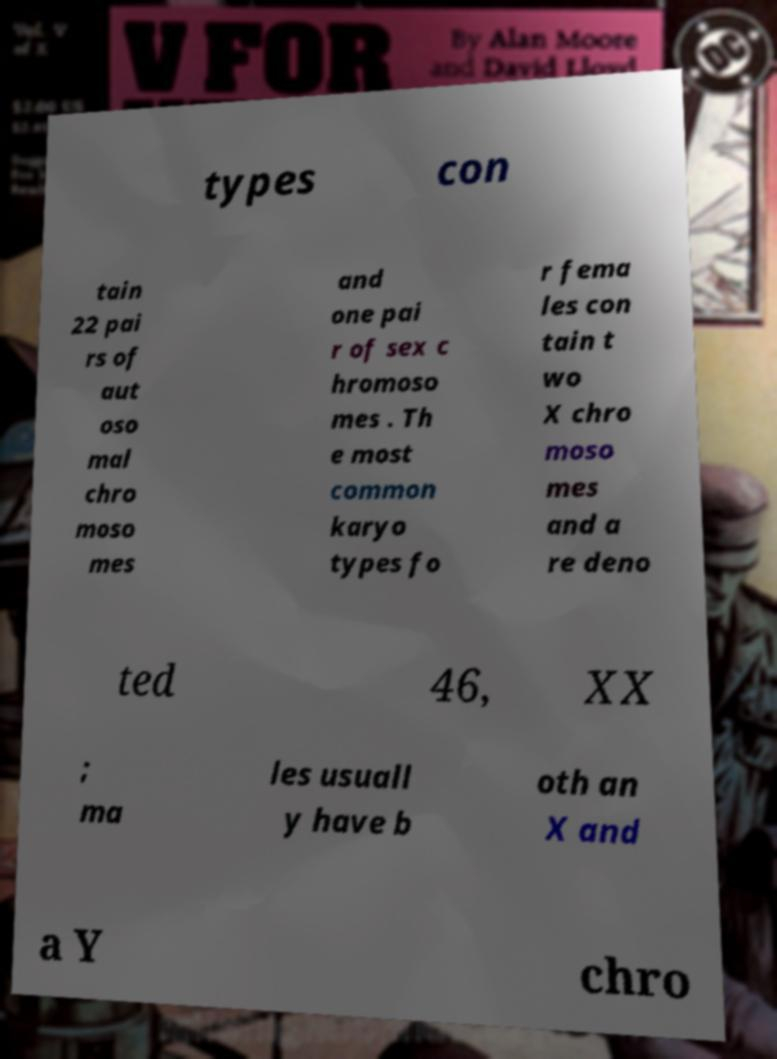Could you extract and type out the text from this image? types con tain 22 pai rs of aut oso mal chro moso mes and one pai r of sex c hromoso mes . Th e most common karyo types fo r fema les con tain t wo X chro moso mes and a re deno ted 46, XX ; ma les usuall y have b oth an X and a Y chro 